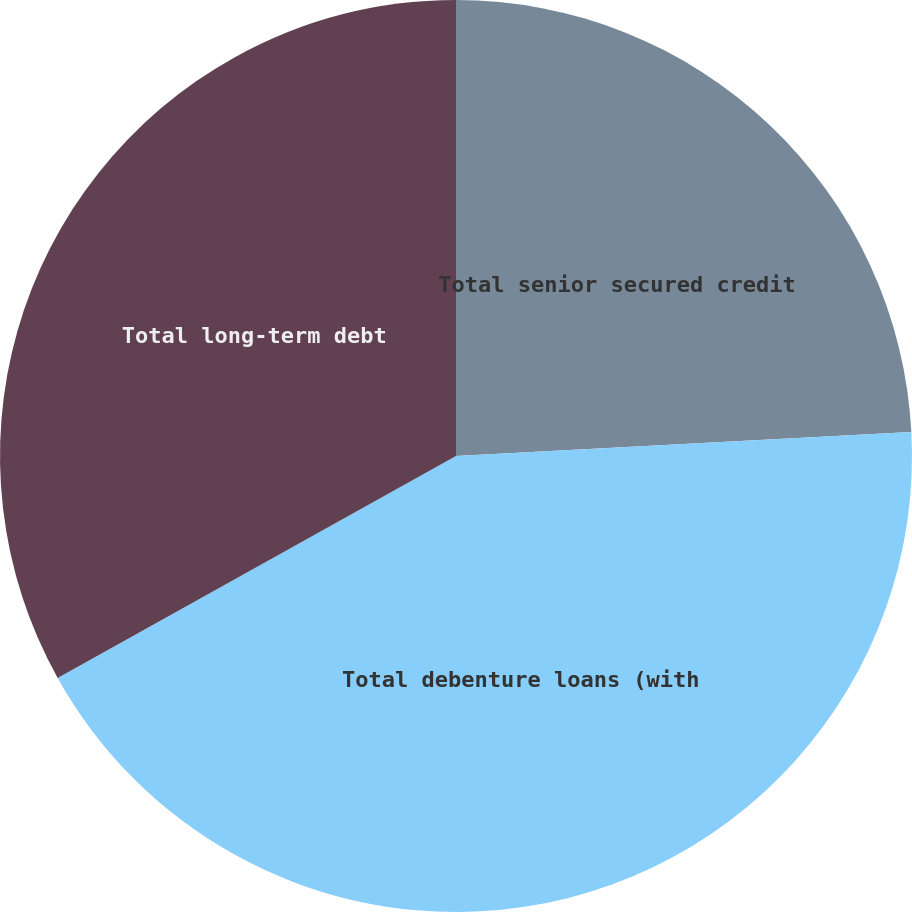Convert chart. <chart><loc_0><loc_0><loc_500><loc_500><pie_chart><fcel>Total senior secured credit<fcel>Total debenture loans (with<fcel>Total long-term debt<nl><fcel>24.16%<fcel>42.75%<fcel>33.09%<nl></chart> 